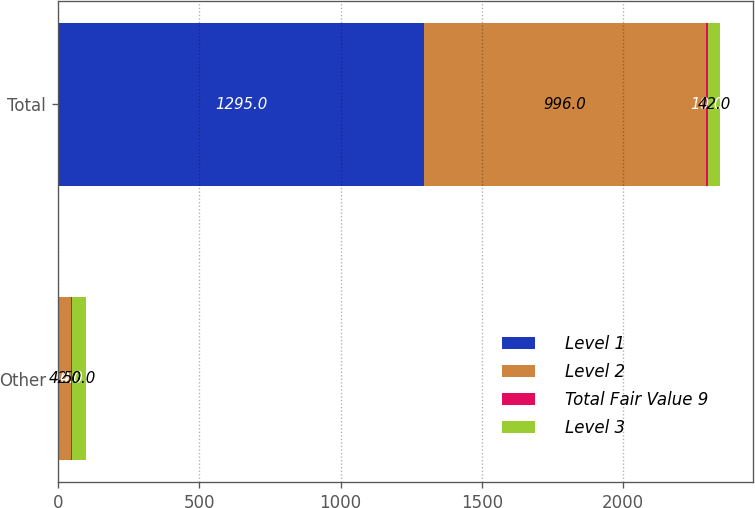Convert chart. <chart><loc_0><loc_0><loc_500><loc_500><stacked_bar_chart><ecel><fcel>Other<fcel>Total<nl><fcel>Level 1<fcel>4<fcel>1295<nl><fcel>Level 2<fcel>42<fcel>996<nl><fcel>Total Fair Value 9<fcel>4<fcel>10<nl><fcel>Level 3<fcel>50<fcel>42<nl></chart> 